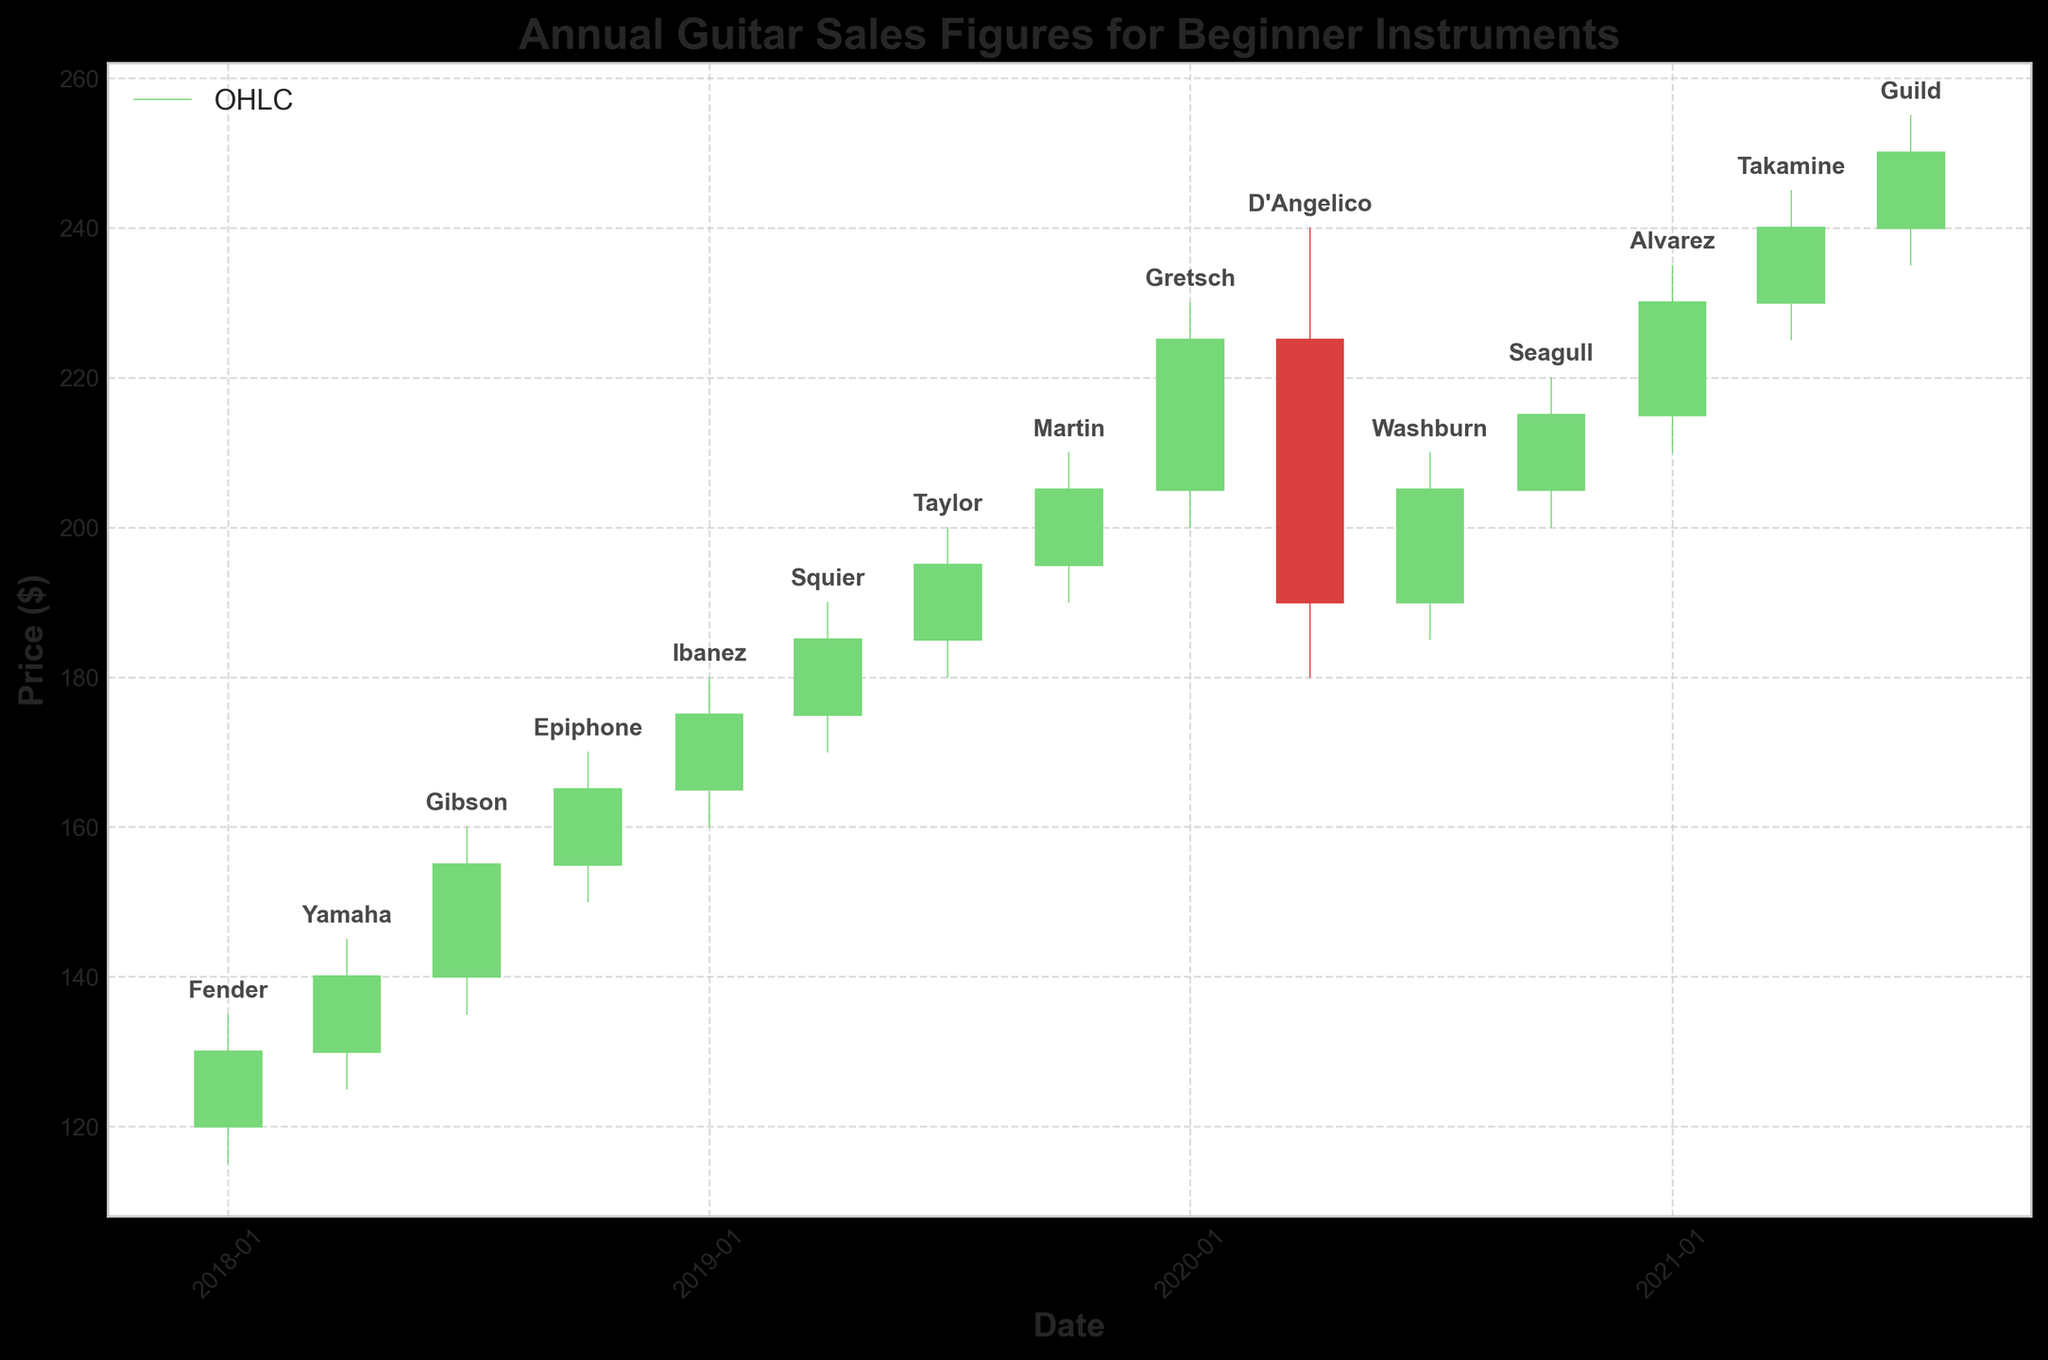What is the title of the chart? The title of the chart is typically located at the top and is a textual element that summarizes the main idea of the chart. In this case, it is likely to state what the chart represents regarding guitar sales figures.
Answer: Annual Guitar Sales Figures for Beginner Instruments What does the y-axis represent in this chart? The y-axis usually indicates the dependent variable in a chart. Here, it shows the price in dollars, representing the sales figures of guitars over time.
Answer: Price ($) How many different guitar brands are displayed in the chart? By counting the unique brand labels annotated near the high price points in the chart, we can determine the number of different guitar brands shown.
Answer: 14 Which guitar brand had the highest sales figure in 2020 and what was the high price? To find the highest sales figure for 2020, we look at the highest high price point in 2020, and the corresponding annotation will show the brand name.
Answer: Gretsch, 230 Which quarter in the data shows the highest market volatility and what is the numerical difference between the high and low prices? Market volatility can be identified by looking for the largest range between high and low prices in any quarter. Here, the significant difference in volatility appears in 2020-04-01, identified by subtracting the low price from the high price.
Answer: 60 Which brand had the sharpest decline in prices, and what timeline is this observed in? A sharp decline in prices can be observed by identifying periods where the closing price is significantly lower than the opening price, or where there's a significant drop over quarters. In this data, D'Angelico in 2020-04-01 had a large decline.
Answer: D'Angelico, 2020 Q1 to Q2 How did the sales figures for Fender change from the start to the end of the observation period? To understand the sales trend of Fender, compare the initial and final sales figures visualized by the opening and closing prices. Fender's stats start at 120 and the final data point (for Guild) is 250.
Answer: Increased Which guitar brand showcased the most consistent sales figures and how can you identify it? Consistent sales can be identified by small differences between high and low prices and between opening and closing prices. Brands with these characteristics over subsequent quarters would be considered consistent. Alvarez, 2021-01-01 to 2021-04-01, shows moderate consistency in these ranges, and other brands might be checked similarly.
Answer: Alvarez 